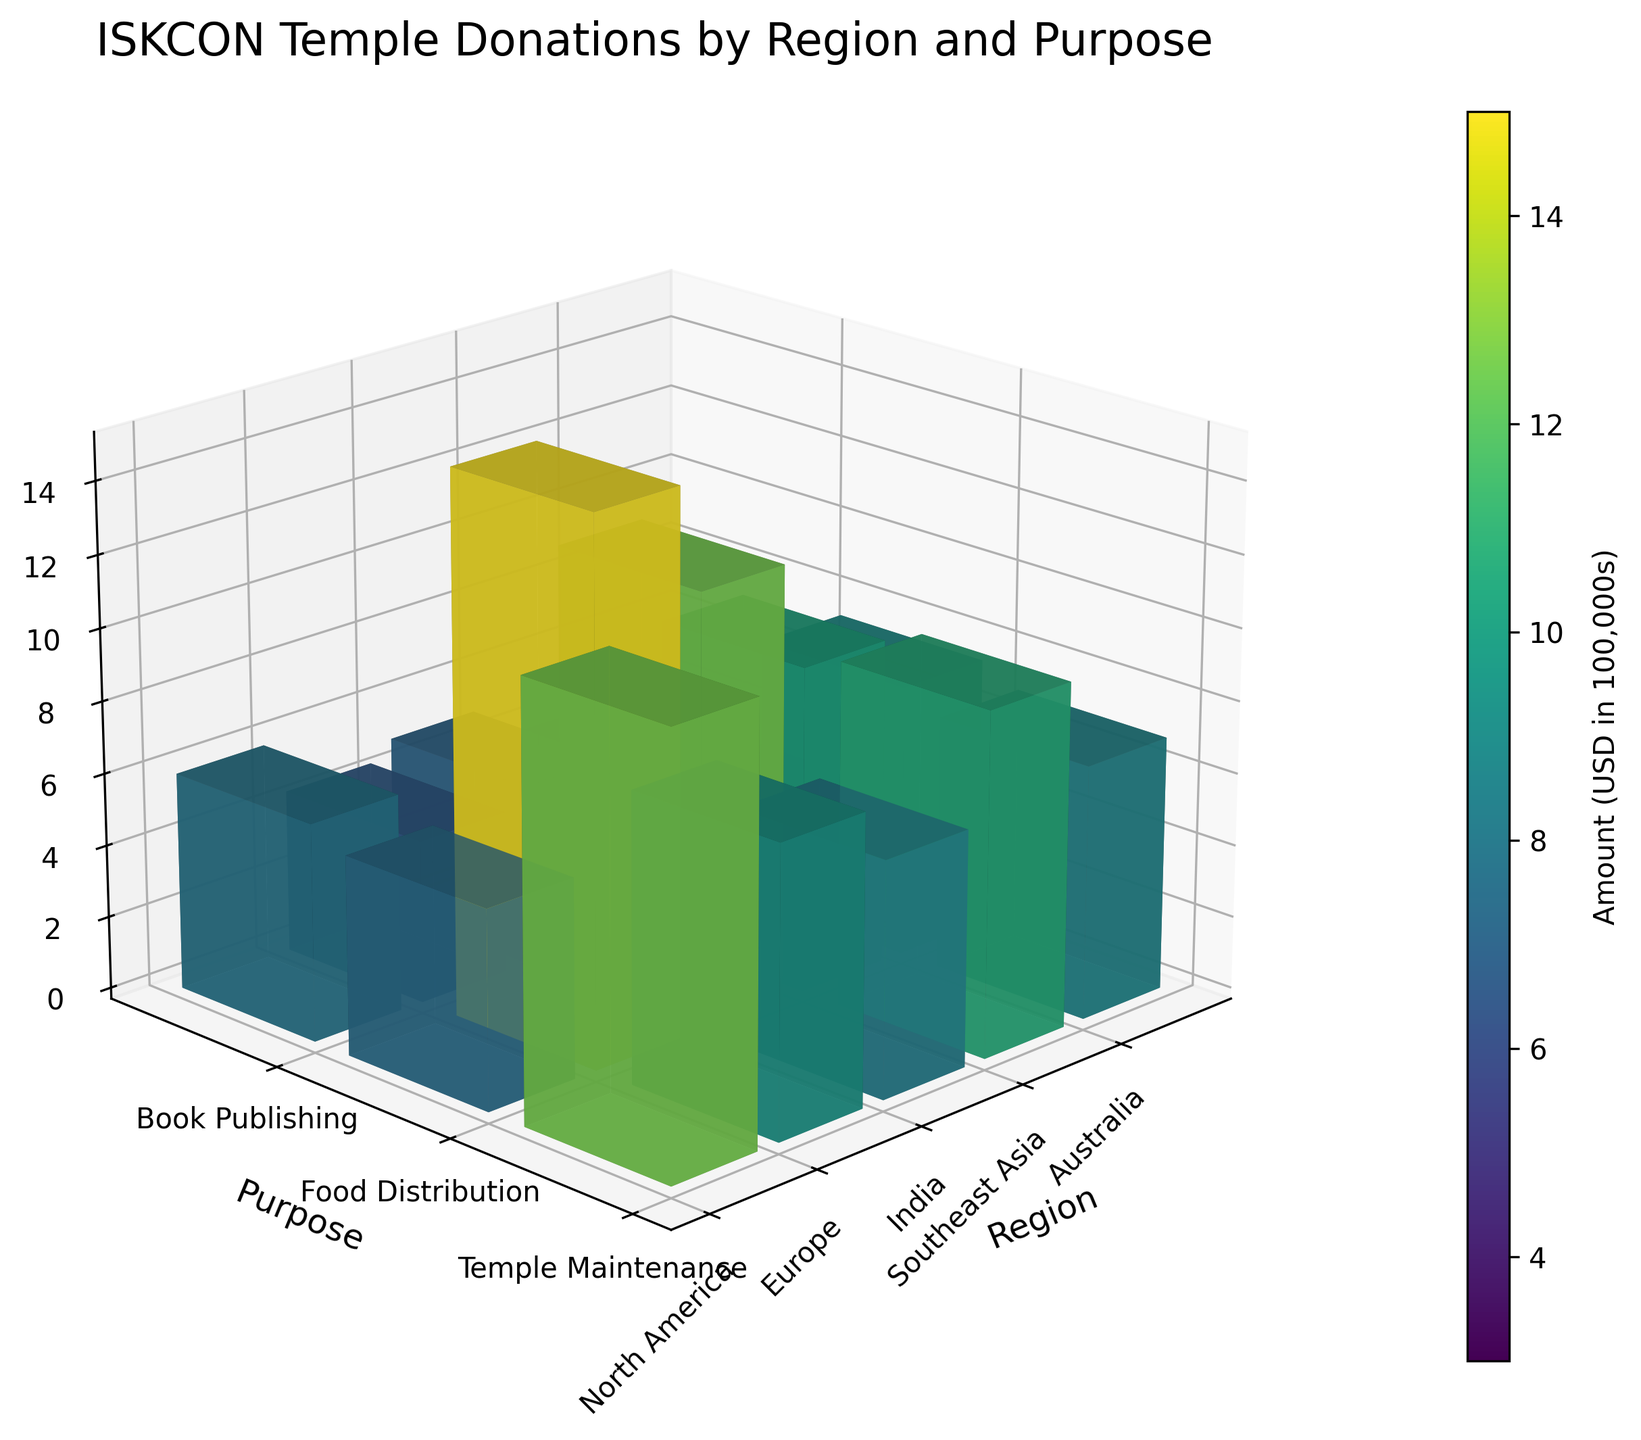What is the title of the figure? The title is usually placed at the top of the figure. It helps to summarize the content of the plot.
Answer: ISKCON Temple Donations by Region and Purpose What does each bar in the figure represent? Each bar represents the donation amount for a specific purpose within a specific region. These bars are plotted in 3D to show the comparison across different regions and purposes.
Answer: Donation amount for a specific purpose and region Which region has the highest donation for Temple Maintenance? Look at the bars under the 'Temple Maintenance' category and determine which region has the tallest bar.
Answer: India Among all regions, which region has the least donation for Book Publishing? Look at all the bars associated with 'Book Publishing' and find the smallest one.
Answer: Australia What is the color gradient of the bars used in the figure? This can be determined by observing the colors used in the bars in the figure. They usually follow a gradient system to represent different values.
Answer: Viridis color map How does the donation for Food Distribution in North America compare to that in Southeast Asia? Compare the height of the bars representing 'Food Distribution' in 'North America' and 'Southeast Asia'. The bar that is taller represents a higher donation amount.
Answer: North America > Southeast Asia What is the combined donation amount for Temple Maintenance across all regions? Sum the heights of all bars under 'Temple Maintenance' category across all regions. The height values need to be converted back from the scale used in the plot. For example, add (1200000 + 950000 + 1500000 + 750000 + 500000).
Answer: $4,900,000 Which purpose has received the most overall donations? Sum the heights of bars across all regions for each purpose and compare the total values. The purpose with the highest total represents the one with the most donations.
Answer: Temple Maintenance Which region receives the highest combined donations for all purposes? Sum the heights of all bars within a region and compare the total values across regions. The region with the highest total amount represents the highest combined donations.
Answer: India 